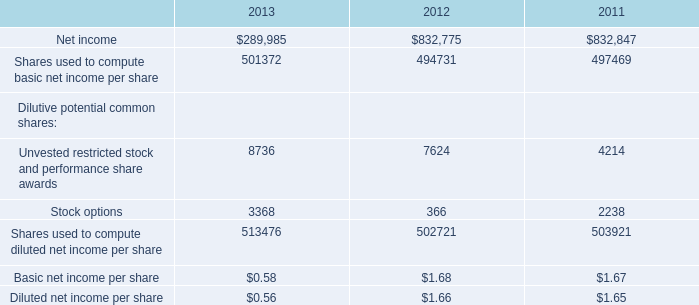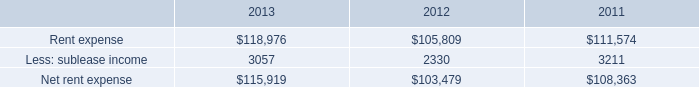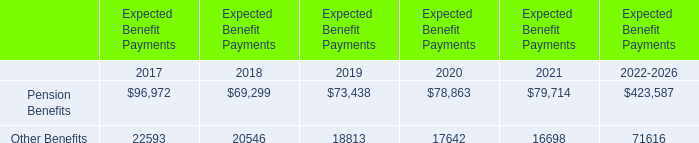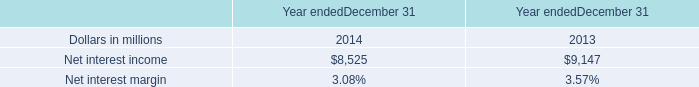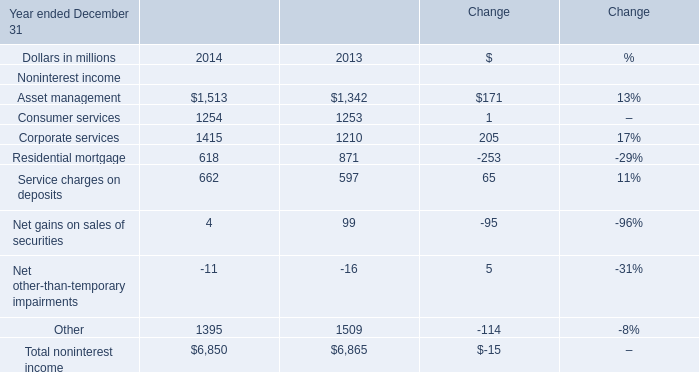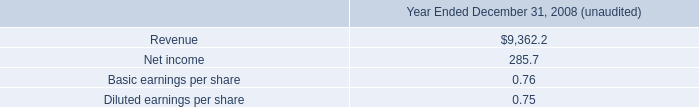what's the total amount of Net interest income of Year endedDecember 31 2014, and Other of Change 2014 ? 
Computations: (8525.0 + 1395.0)
Answer: 9920.0. 